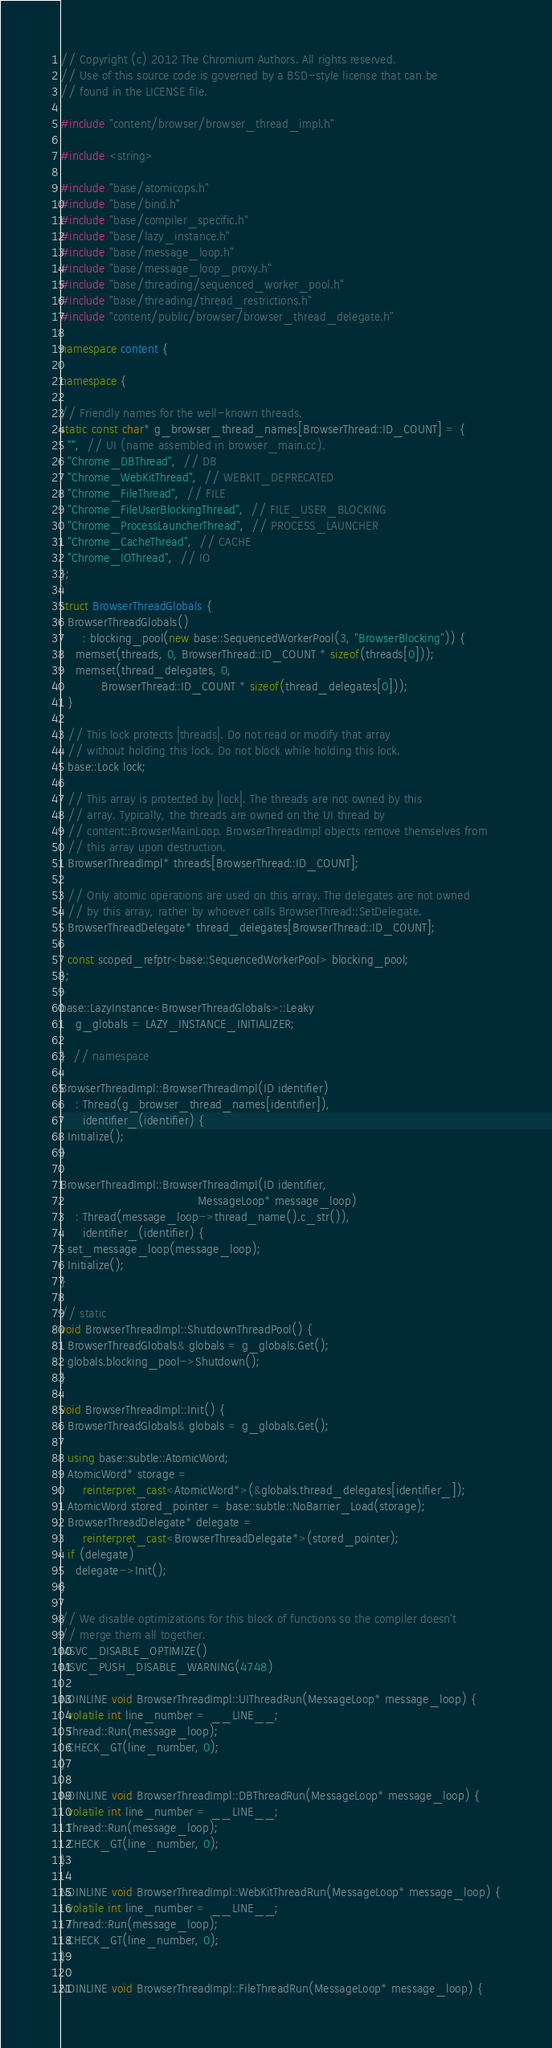Convert code to text. <code><loc_0><loc_0><loc_500><loc_500><_C++_>// Copyright (c) 2012 The Chromium Authors. All rights reserved.
// Use of this source code is governed by a BSD-style license that can be
// found in the LICENSE file.

#include "content/browser/browser_thread_impl.h"

#include <string>

#include "base/atomicops.h"
#include "base/bind.h"
#include "base/compiler_specific.h"
#include "base/lazy_instance.h"
#include "base/message_loop.h"
#include "base/message_loop_proxy.h"
#include "base/threading/sequenced_worker_pool.h"
#include "base/threading/thread_restrictions.h"
#include "content/public/browser/browser_thread_delegate.h"

namespace content {

namespace {

// Friendly names for the well-known threads.
static const char* g_browser_thread_names[BrowserThread::ID_COUNT] = {
  "",  // UI (name assembled in browser_main.cc).
  "Chrome_DBThread",  // DB
  "Chrome_WebKitThread",  // WEBKIT_DEPRECATED
  "Chrome_FileThread",  // FILE
  "Chrome_FileUserBlockingThread",  // FILE_USER_BLOCKING
  "Chrome_ProcessLauncherThread",  // PROCESS_LAUNCHER
  "Chrome_CacheThread",  // CACHE
  "Chrome_IOThread",  // IO
};

struct BrowserThreadGlobals {
  BrowserThreadGlobals()
      : blocking_pool(new base::SequencedWorkerPool(3, "BrowserBlocking")) {
    memset(threads, 0, BrowserThread::ID_COUNT * sizeof(threads[0]));
    memset(thread_delegates, 0,
           BrowserThread::ID_COUNT * sizeof(thread_delegates[0]));
  }

  // This lock protects |threads|. Do not read or modify that array
  // without holding this lock. Do not block while holding this lock.
  base::Lock lock;

  // This array is protected by |lock|. The threads are not owned by this
  // array. Typically, the threads are owned on the UI thread by
  // content::BrowserMainLoop. BrowserThreadImpl objects remove themselves from
  // this array upon destruction.
  BrowserThreadImpl* threads[BrowserThread::ID_COUNT];

  // Only atomic operations are used on this array. The delegates are not owned
  // by this array, rather by whoever calls BrowserThread::SetDelegate.
  BrowserThreadDelegate* thread_delegates[BrowserThread::ID_COUNT];

  const scoped_refptr<base::SequencedWorkerPool> blocking_pool;
};

base::LazyInstance<BrowserThreadGlobals>::Leaky
    g_globals = LAZY_INSTANCE_INITIALIZER;

}  // namespace

BrowserThreadImpl::BrowserThreadImpl(ID identifier)
    : Thread(g_browser_thread_names[identifier]),
      identifier_(identifier) {
  Initialize();
}

BrowserThreadImpl::BrowserThreadImpl(ID identifier,
                                     MessageLoop* message_loop)
    : Thread(message_loop->thread_name().c_str()),
      identifier_(identifier) {
  set_message_loop(message_loop);
  Initialize();
}

// static
void BrowserThreadImpl::ShutdownThreadPool() {
  BrowserThreadGlobals& globals = g_globals.Get();
  globals.blocking_pool->Shutdown();
}

void BrowserThreadImpl::Init() {
  BrowserThreadGlobals& globals = g_globals.Get();

  using base::subtle::AtomicWord;
  AtomicWord* storage =
      reinterpret_cast<AtomicWord*>(&globals.thread_delegates[identifier_]);
  AtomicWord stored_pointer = base::subtle::NoBarrier_Load(storage);
  BrowserThreadDelegate* delegate =
      reinterpret_cast<BrowserThreadDelegate*>(stored_pointer);
  if (delegate)
    delegate->Init();
}

// We disable optimizations for this block of functions so the compiler doesn't
// merge them all together.
MSVC_DISABLE_OPTIMIZE()
MSVC_PUSH_DISABLE_WARNING(4748)

NOINLINE void BrowserThreadImpl::UIThreadRun(MessageLoop* message_loop) {
  volatile int line_number = __LINE__;
  Thread::Run(message_loop);
  CHECK_GT(line_number, 0);
}

NOINLINE void BrowserThreadImpl::DBThreadRun(MessageLoop* message_loop) {
  volatile int line_number = __LINE__;
  Thread::Run(message_loop);
  CHECK_GT(line_number, 0);
}

NOINLINE void BrowserThreadImpl::WebKitThreadRun(MessageLoop* message_loop) {
  volatile int line_number = __LINE__;
  Thread::Run(message_loop);
  CHECK_GT(line_number, 0);
}

NOINLINE void BrowserThreadImpl::FileThreadRun(MessageLoop* message_loop) {</code> 